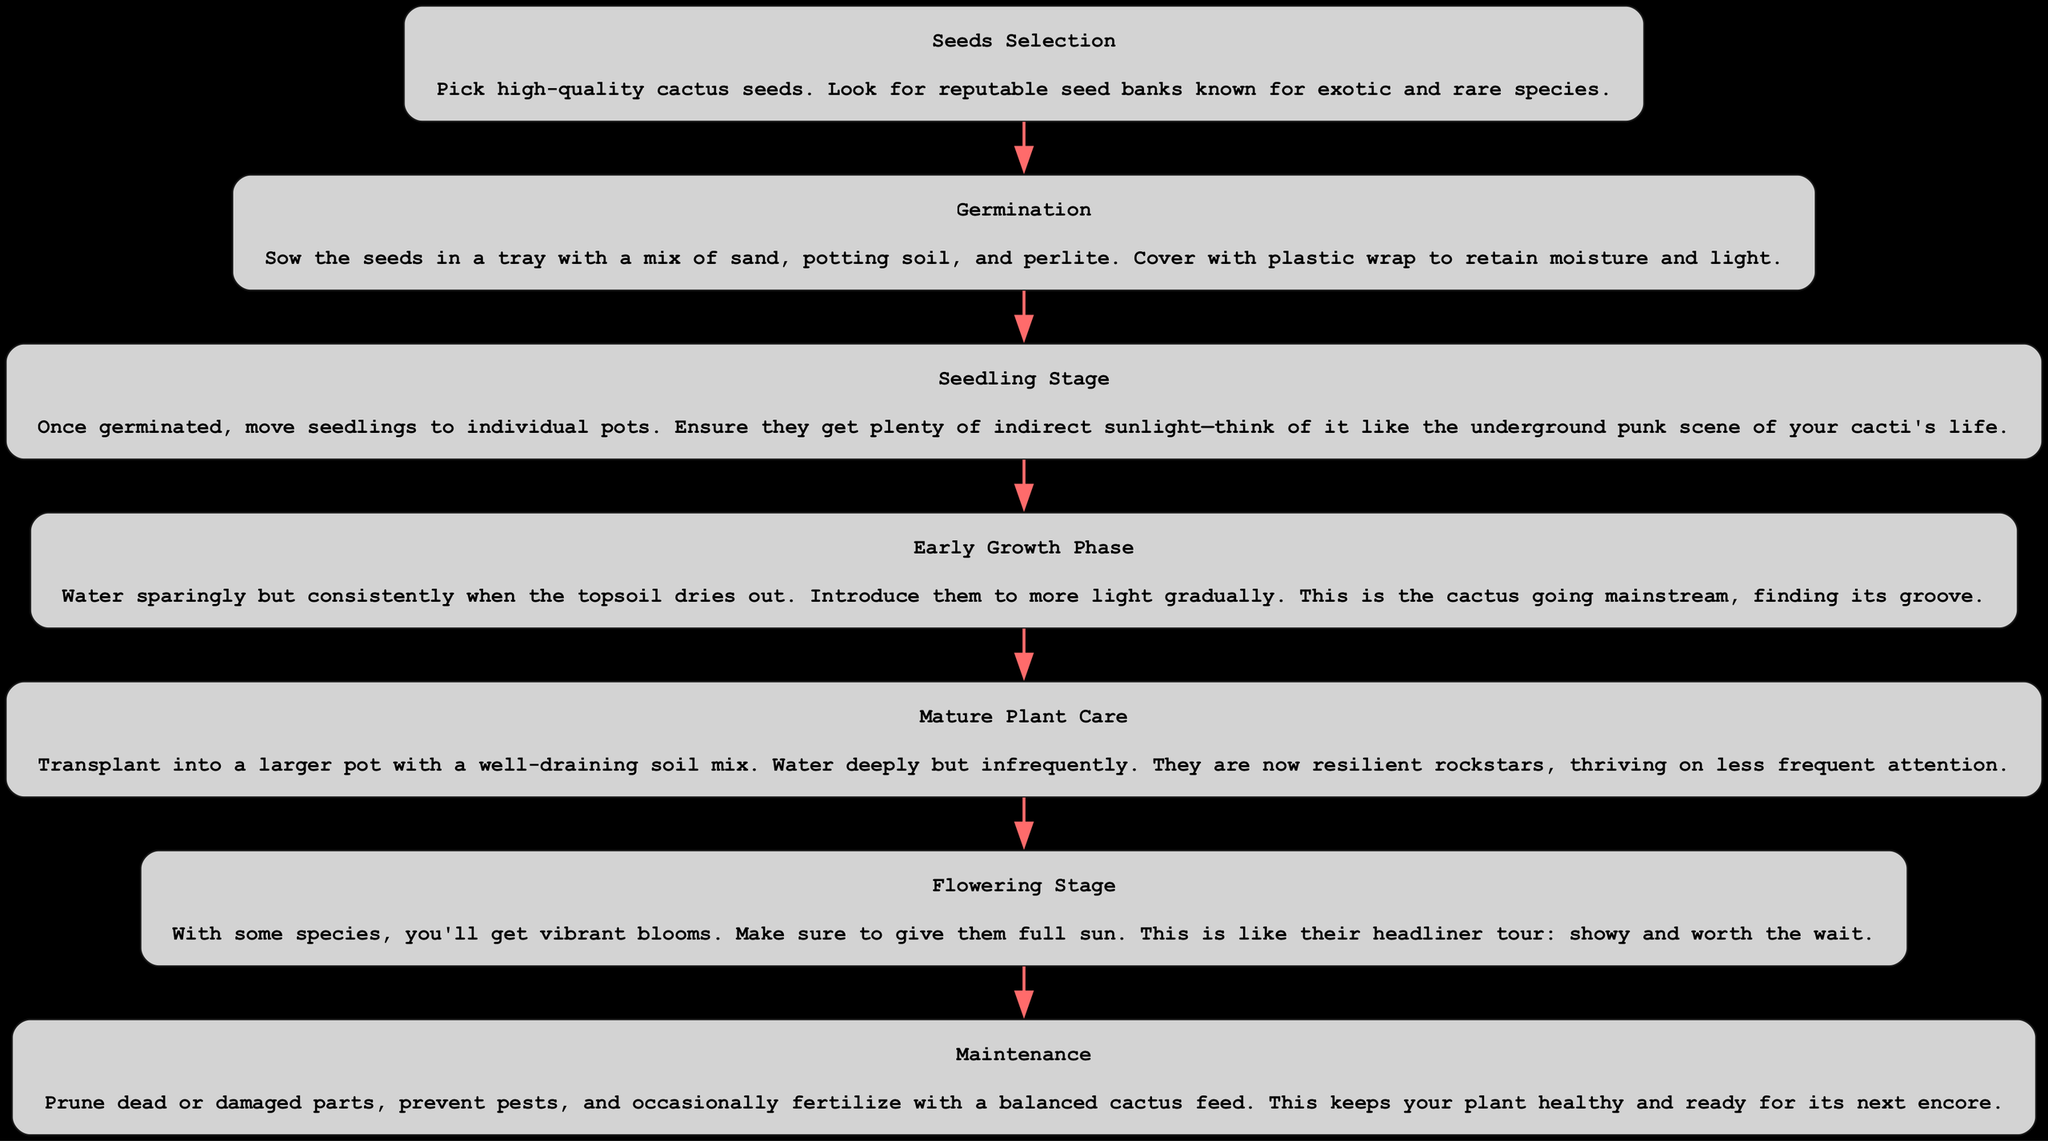What is the first stage in the diagram? The first element or node in the diagram is "Seeds Selection," which is the starting point of the growing process.
Answer: Seeds Selection How many total stages are represented in the diagram? By counting the individual nodes presented from start to finish, there are seven distinct stages outlined in the diagram.
Answer: Seven What follows the "Germination" stage? The stage that comes directly after "Germination" is "Seedling Stage," indicating the progression in the cactus growing process.
Answer: Seedling Stage Which stage emphasizes the use of indirect sunlight? The "Seedling Stage" highlights the need for indirect sunlight, referring to the care of young cactus plants.
Answer: Seedling Stage What stage represents the cactus’s vibrant blooms? The stage dedicated to the colorful blooms is the "Flowering Stage," showcasing a critical aspect of some cactus species.
Answer: Flowering Stage Which stage involves moving the cactus to a larger pot? "Mature Plant Care" describes the necessary action of transplanting the cactus into a larger pot for better growth.
Answer: Mature Plant Care How is the "Early Growth Phase" described in the context of cactus development? The "Early Growth Phase" is likened to the cactus "going mainstream, finding its groove," indicating a transition to more light and consistent care.
Answer: going mainstream What does the diagram indicate should be done during "Maintenance"? "Maintenance" includes tasks like pruning dead parts and preventing pests, ensuring ongoing health and vitality for the cactus plant.
Answer: Prune, prevent pests What is the main focus during the "Flowering Stage"? The main focus during the "Flowering Stage" is to provide full sunlight for the cactus to encourage blooming.
Answer: Full sun 